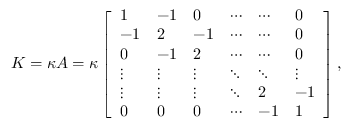<formula> <loc_0><loc_0><loc_500><loc_500>K = \kappa A = \kappa \left [ \begin{array} { l l l l l l } { 1 } & { - 1 } & { 0 } & { \cdots } & { \cdots } & { 0 } \\ { - 1 } & { 2 } & { - 1 } & { \cdots } & { \cdots } & { 0 } \\ { 0 } & { - 1 } & { 2 } & { \cdots } & { \cdots } & { 0 } \\ { \vdots } & { \vdots } & { \vdots } & { \ddots } & { \ddots } & { \vdots } \\ { \vdots } & { \vdots } & { \vdots } & { \ddots } & { 2 } & { - 1 } \\ { 0 } & { 0 } & { 0 } & { \cdots } & { - 1 } & { 1 } \end{array} \right ] ,</formula> 